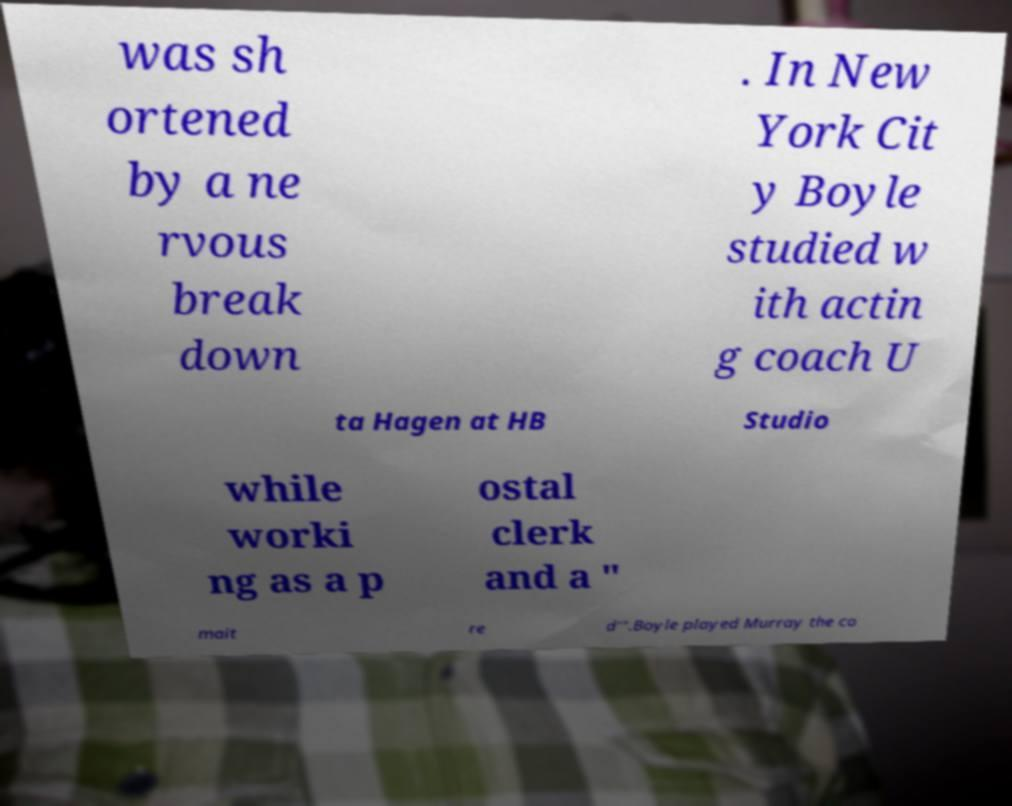Please read and relay the text visible in this image. What does it say? was sh ortened by a ne rvous break down . In New York Cit y Boyle studied w ith actin g coach U ta Hagen at HB Studio while worki ng as a p ostal clerk and a " mait re d'".Boyle played Murray the co 